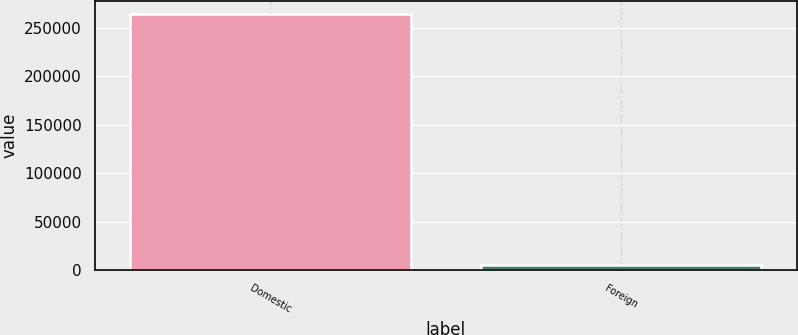Convert chart to OTSL. <chart><loc_0><loc_0><loc_500><loc_500><bar_chart><fcel>Domestic<fcel>Foreign<nl><fcel>264438<fcel>5687<nl></chart> 